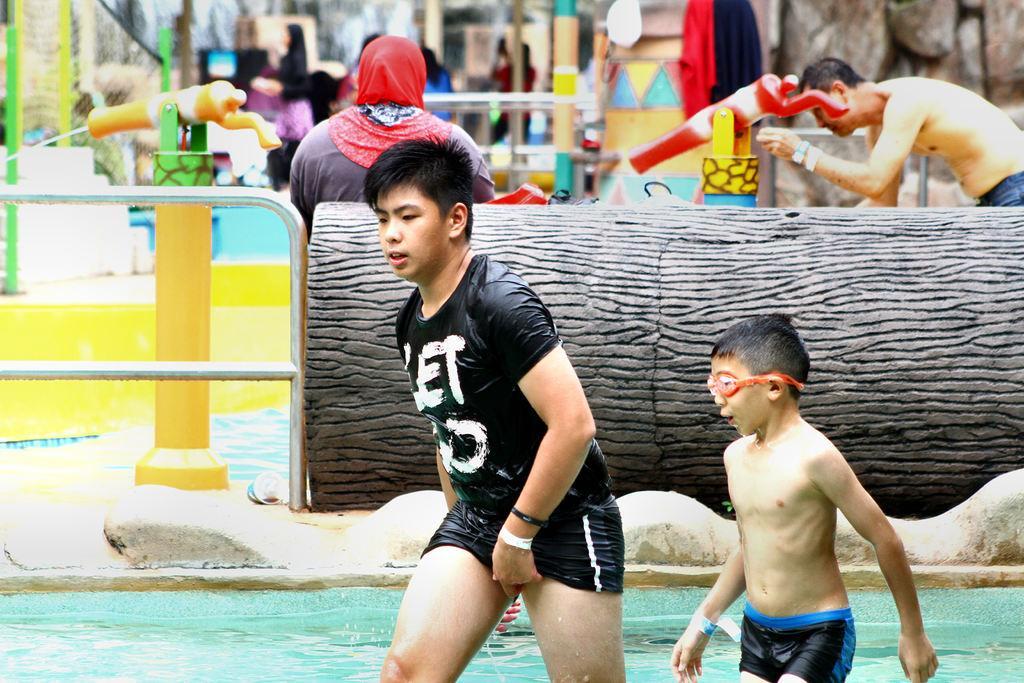In one or two sentences, can you explain what this image depicts? In this picture there are people and we can see water, rods, poles, clothes and objects. In the background of the image it is blurry and we can see people and objects. 